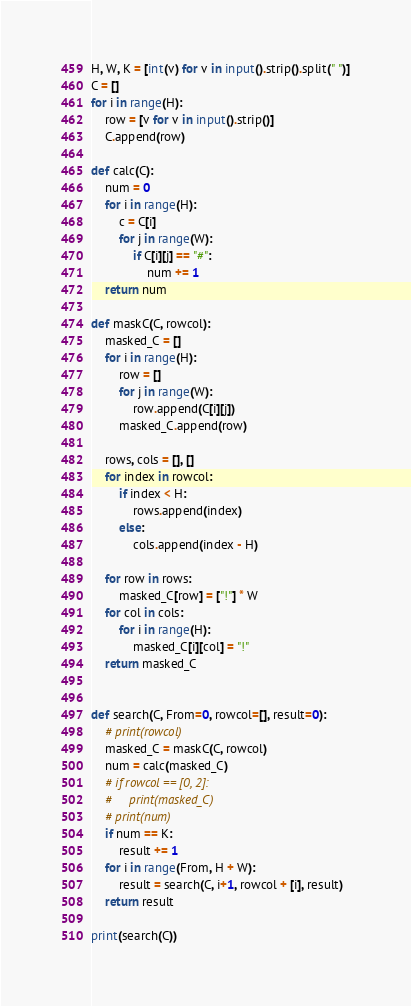<code> <loc_0><loc_0><loc_500><loc_500><_Python_>H, W, K = [int(v) for v in input().strip().split(" ")]
C = []
for i in range(H):
    row = [v for v in input().strip()]
    C.append(row)

def calc(C):
    num = 0
    for i in range(H):
        c = C[i]
        for j in range(W):
            if C[i][j] == "#":
                num += 1
    return num

def maskC(C, rowcol):
    masked_C = []
    for i in range(H):
        row = []
        for j in range(W):
            row.append(C[i][j])
        masked_C.append(row)

    rows, cols = [], []
    for index in rowcol:
        if index < H:
            rows.append(index)
        else:
            cols.append(index - H)

    for row in rows:
        masked_C[row] = ["!"] * W
    for col in cols:
        for i in range(H):
            masked_C[i][col] = "!"
    return masked_C


def search(C, From=0, rowcol=[], result=0):
    # print(rowcol)
    masked_C = maskC(C, rowcol)
    num = calc(masked_C)
    # if rowcol == [0, 2]:
    #     print(masked_C)
    # print(num)
    if num == K:
        result += 1
    for i in range(From, H + W):
        result = search(C, i+1, rowcol + [i], result)
    return result

print(search(C))</code> 